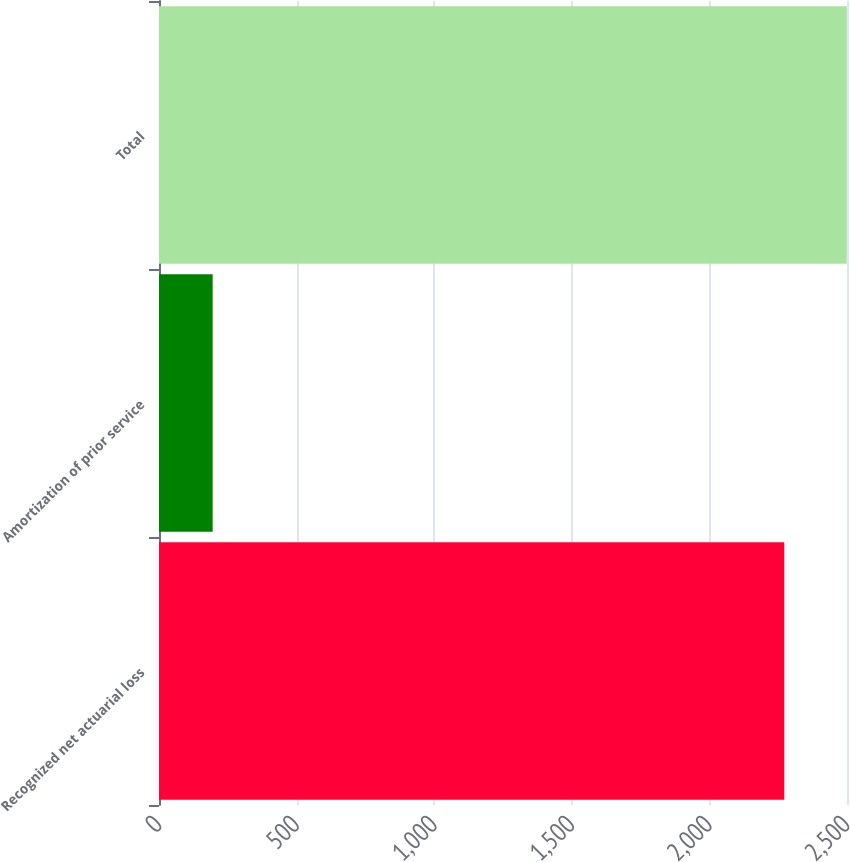<chart> <loc_0><loc_0><loc_500><loc_500><bar_chart><fcel>Recognized net actuarial loss<fcel>Amortization of prior service<fcel>Total<nl><fcel>2272<fcel>195<fcel>2499.2<nl></chart> 